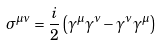<formula> <loc_0><loc_0><loc_500><loc_500>\sigma ^ { \mu \nu } = \frac { i } { 2 } \left ( \gamma ^ { \mu } \gamma ^ { \nu } - \gamma ^ { \nu } \gamma ^ { \mu } \right ) \,</formula> 